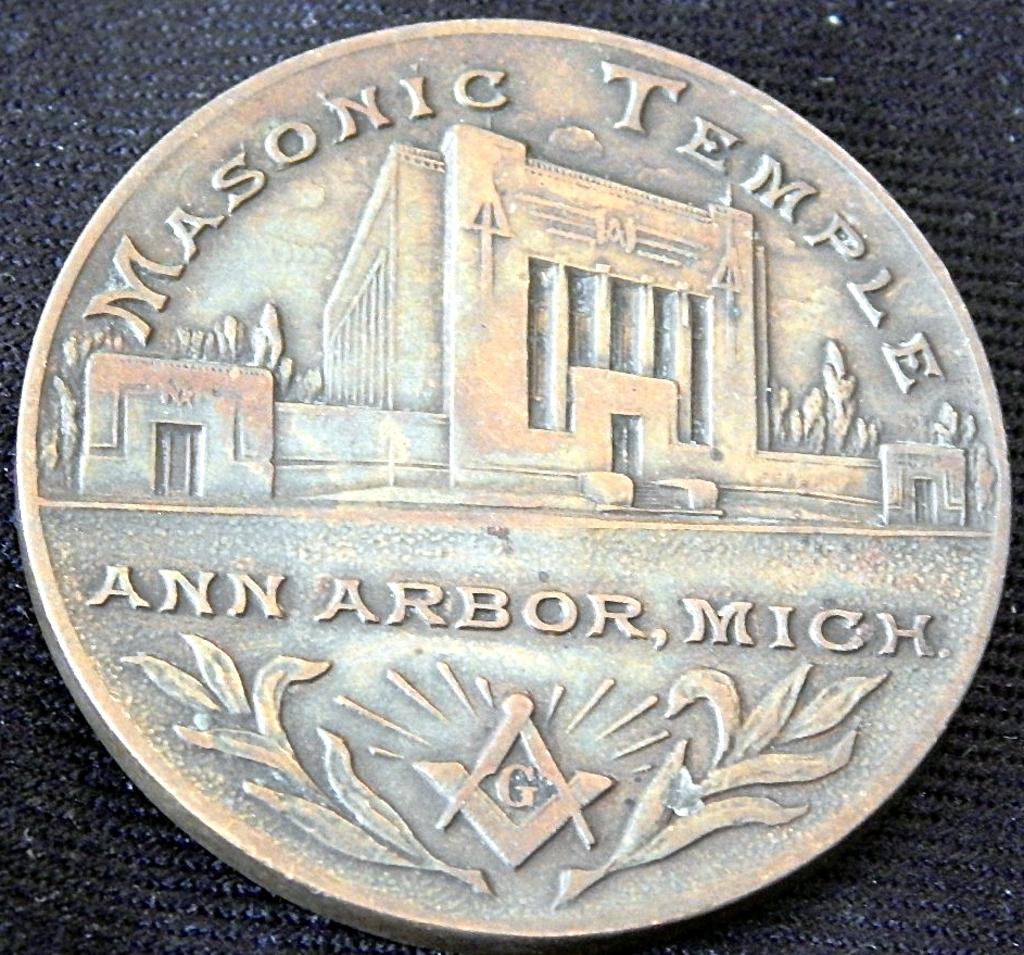<image>
Provide a brief description of the given image. The Masonic Temple token is from Ann Arbor, Michigan. 